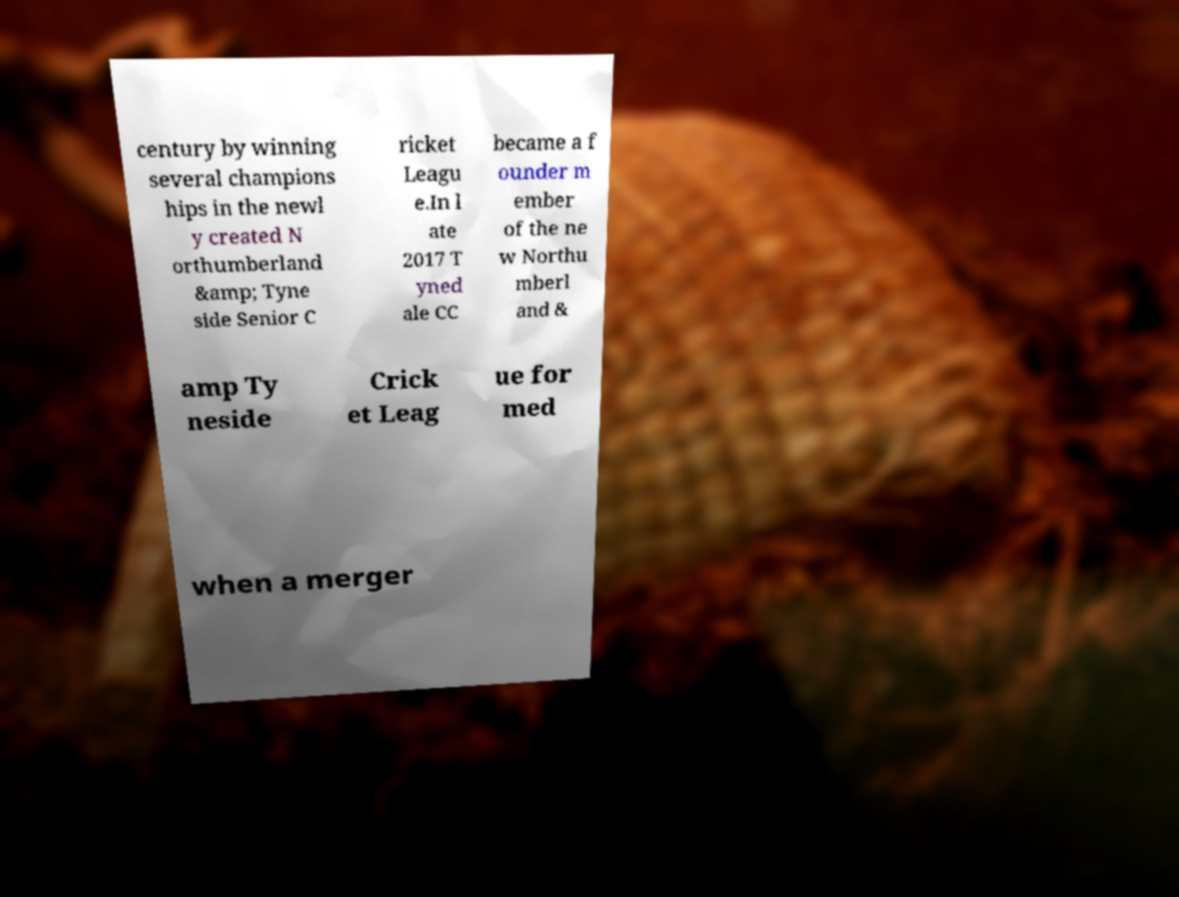Could you assist in decoding the text presented in this image and type it out clearly? century by winning several champions hips in the newl y created N orthumberland &amp; Tyne side Senior C ricket Leagu e.In l ate 2017 T yned ale CC became a f ounder m ember of the ne w Northu mberl and & amp Ty neside Crick et Leag ue for med when a merger 